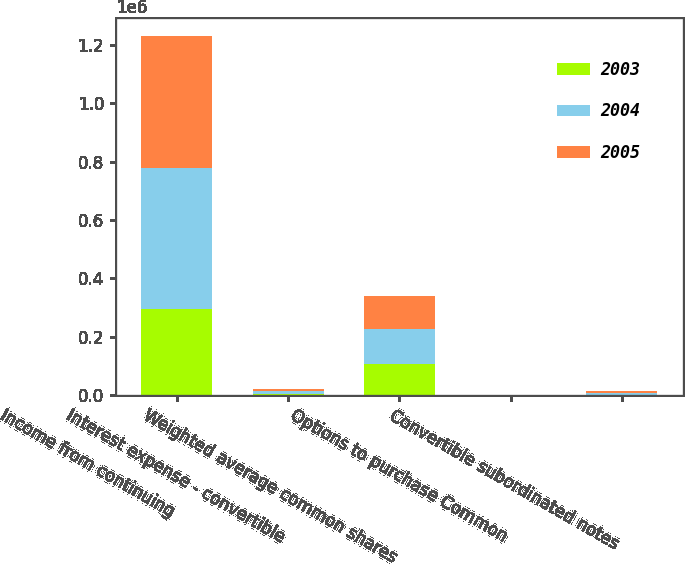Convert chart. <chart><loc_0><loc_0><loc_500><loc_500><stacked_bar_chart><ecel><fcel>Income from continuing<fcel>Interest expense - convertible<fcel>Weighted average common shares<fcel>Options to purchase Common<fcel>Convertible subordinated notes<nl><fcel>2003<fcel>294461<fcel>2539<fcel>107770<fcel>658<fcel>1445<nl><fcel>2004<fcel>485015<fcel>10141<fcel>117779<fcel>498<fcel>5664<nl><fcel>2005<fcel>453062<fcel>9997<fcel>115954<fcel>777<fcel>5664<nl></chart> 